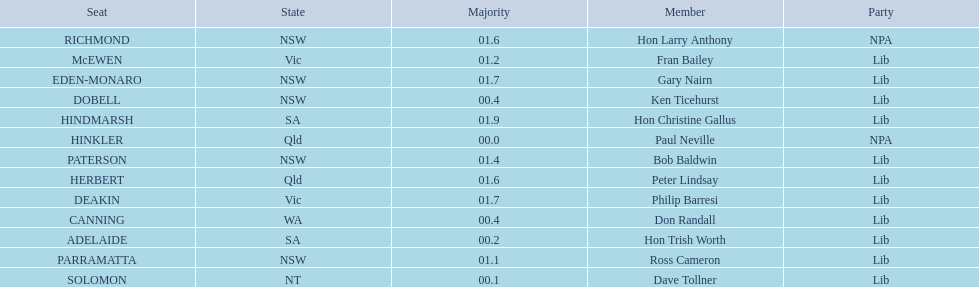Who appears before don randall in the list? Hon Trish Worth. 